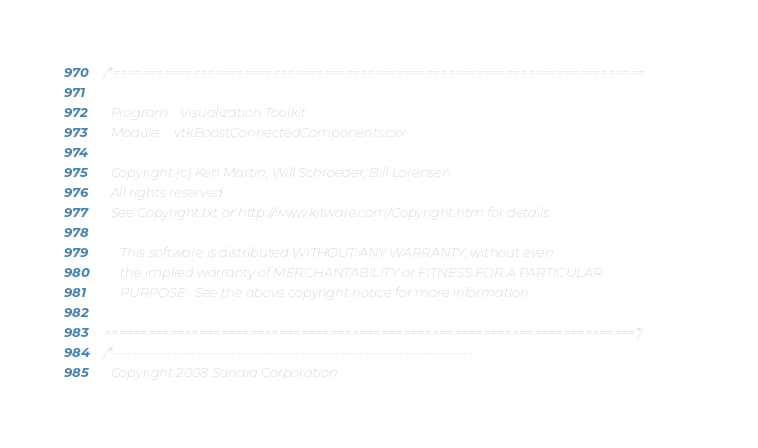Convert code to text. <code><loc_0><loc_0><loc_500><loc_500><_C++_>/*=========================================================================

  Program:   Visualization Toolkit
  Module:    vtkBoostConnectedComponents.cxx

  Copyright (c) Ken Martin, Will Schroeder, Bill Lorensen
  All rights reserved.
  See Copyright.txt or http://www.kitware.com/Copyright.htm for details.

     This software is distributed WITHOUT ANY WARRANTY; without even
     the implied warranty of MERCHANTABILITY or FITNESS FOR A PARTICULAR
     PURPOSE.  See the above copyright notice for more information.

=========================================================================*/
/*-------------------------------------------------------------------------
  Copyright 2008 Sandia Corporation.</code> 